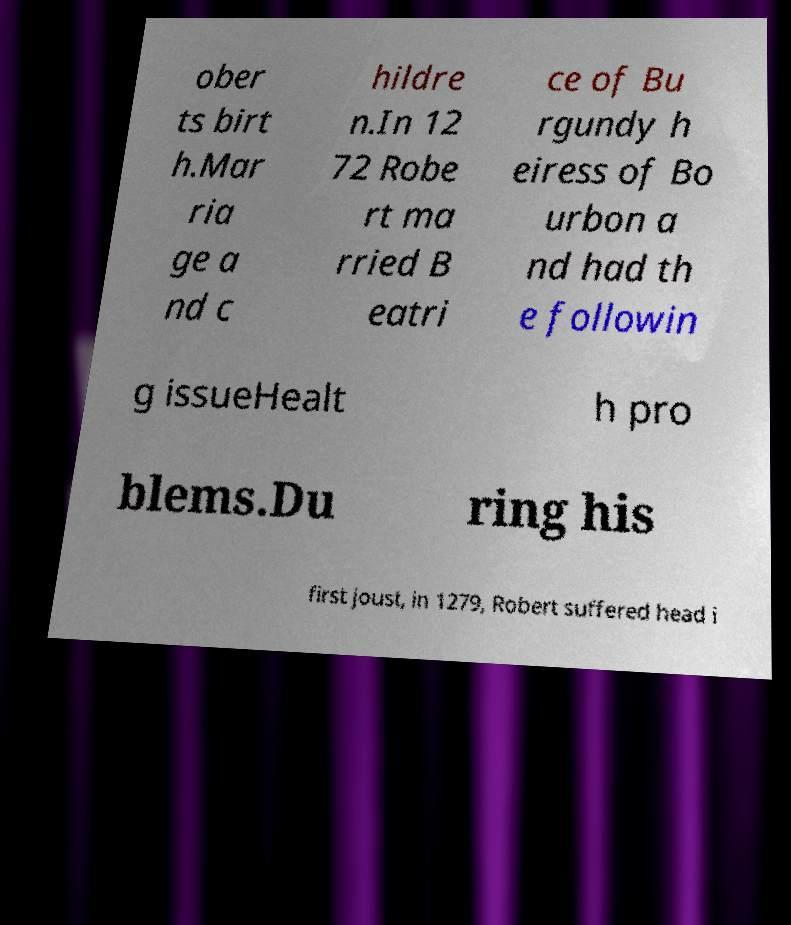Can you read and provide the text displayed in the image?This photo seems to have some interesting text. Can you extract and type it out for me? ober ts birt h.Mar ria ge a nd c hildre n.In 12 72 Robe rt ma rried B eatri ce of Bu rgundy h eiress of Bo urbon a nd had th e followin g issueHealt h pro blems.Du ring his first joust, in 1279, Robert suffered head i 